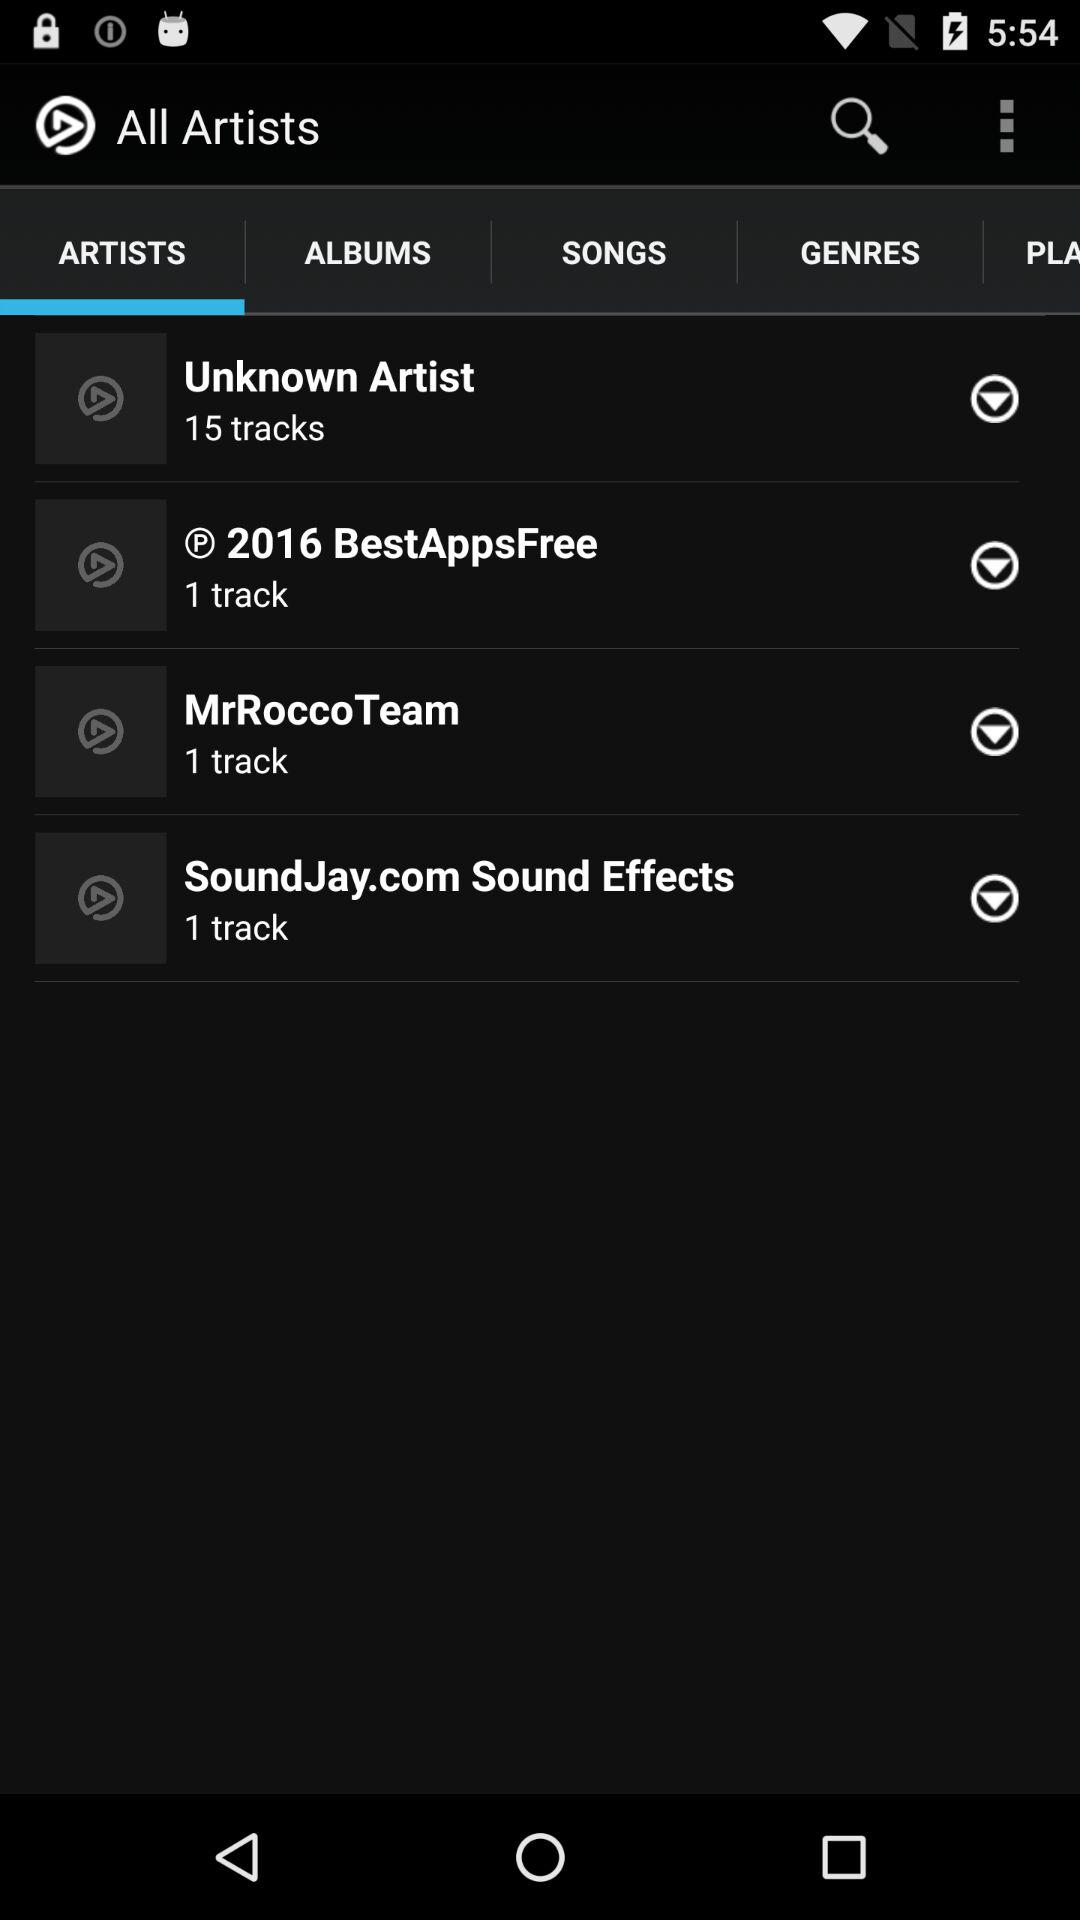What is the app name? The app name is "All Artists". 